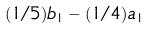Convert formula to latex. <formula><loc_0><loc_0><loc_500><loc_500>( 1 / 5 ) b _ { 1 } - ( 1 / 4 ) a _ { 1 }</formula> 